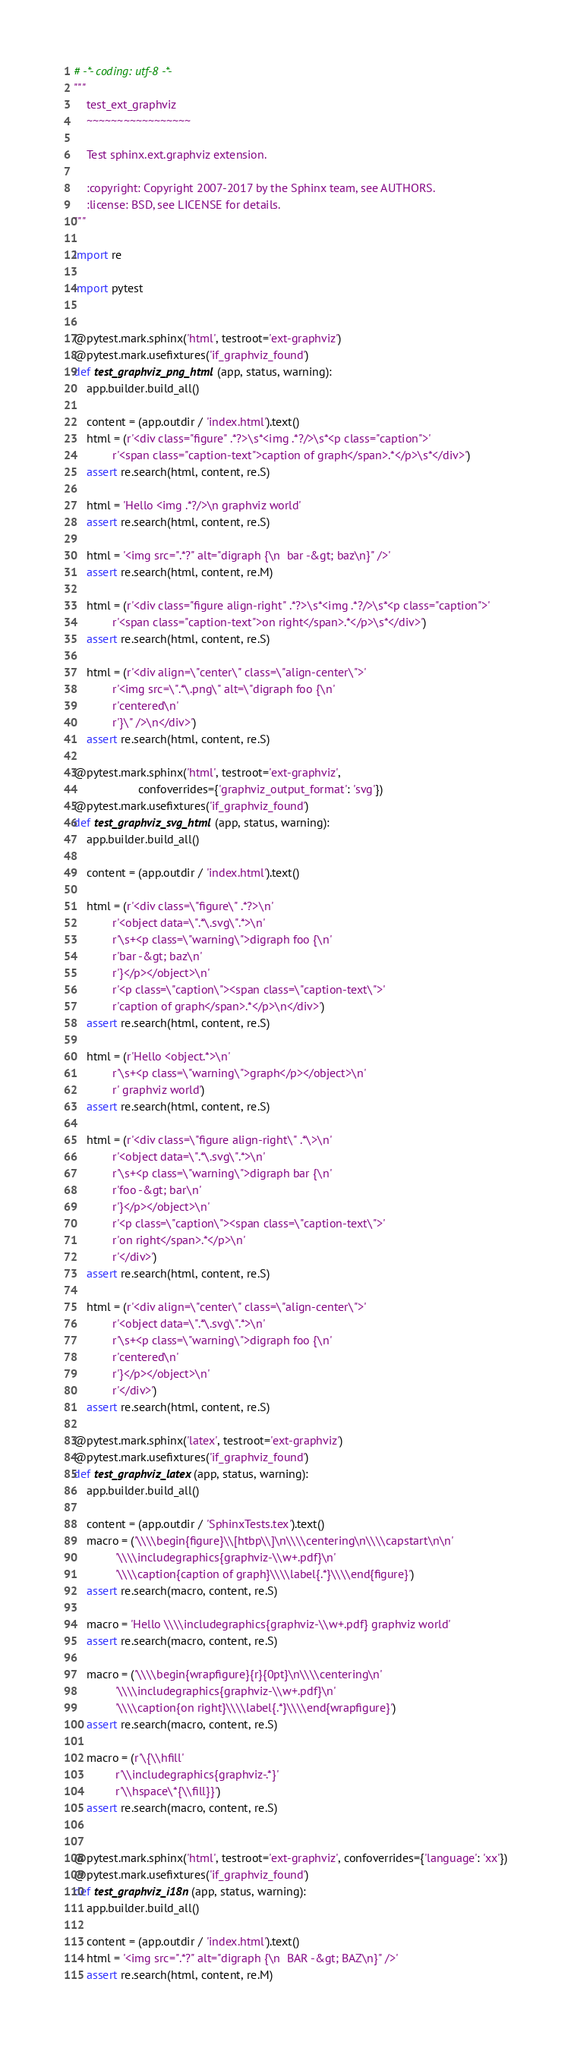Convert code to text. <code><loc_0><loc_0><loc_500><loc_500><_Python_># -*- coding: utf-8 -*-
"""
    test_ext_graphviz
    ~~~~~~~~~~~~~~~~~

    Test sphinx.ext.graphviz extension.

    :copyright: Copyright 2007-2017 by the Sphinx team, see AUTHORS.
    :license: BSD, see LICENSE for details.
"""

import re

import pytest


@pytest.mark.sphinx('html', testroot='ext-graphviz')
@pytest.mark.usefixtures('if_graphviz_found')
def test_graphviz_png_html(app, status, warning):
    app.builder.build_all()

    content = (app.outdir / 'index.html').text()
    html = (r'<div class="figure" .*?>\s*<img .*?/>\s*<p class="caption">'
            r'<span class="caption-text">caption of graph</span>.*</p>\s*</div>')
    assert re.search(html, content, re.S)

    html = 'Hello <img .*?/>\n graphviz world'
    assert re.search(html, content, re.S)

    html = '<img src=".*?" alt="digraph {\n  bar -&gt; baz\n}" />'
    assert re.search(html, content, re.M)

    html = (r'<div class="figure align-right" .*?>\s*<img .*?/>\s*<p class="caption">'
            r'<span class="caption-text">on right</span>.*</p>\s*</div>')
    assert re.search(html, content, re.S)

    html = (r'<div align=\"center\" class=\"align-center\">'
            r'<img src=\".*\.png\" alt=\"digraph foo {\n'
            r'centered\n'
            r'}\" />\n</div>')
    assert re.search(html, content, re.S)

@pytest.mark.sphinx('html', testroot='ext-graphviz',
                    confoverrides={'graphviz_output_format': 'svg'})
@pytest.mark.usefixtures('if_graphviz_found')
def test_graphviz_svg_html(app, status, warning):
    app.builder.build_all()

    content = (app.outdir / 'index.html').text()

    html = (r'<div class=\"figure\" .*?>\n'
            r'<object data=\".*\.svg\".*>\n'
            r'\s+<p class=\"warning\">digraph foo {\n'
            r'bar -&gt; baz\n'
            r'}</p></object>\n'
            r'<p class=\"caption\"><span class=\"caption-text\">'
            r'caption of graph</span>.*</p>\n</div>')
    assert re.search(html, content, re.S)

    html = (r'Hello <object.*>\n'
            r'\s+<p class=\"warning\">graph</p></object>\n'
            r' graphviz world')
    assert re.search(html, content, re.S)

    html = (r'<div class=\"figure align-right\" .*\>\n'
            r'<object data=\".*\.svg\".*>\n'
            r'\s+<p class=\"warning\">digraph bar {\n'
            r'foo -&gt; bar\n'
            r'}</p></object>\n'
            r'<p class=\"caption\"><span class=\"caption-text\">'
            r'on right</span>.*</p>\n'
            r'</div>')
    assert re.search(html, content, re.S)

    html = (r'<div align=\"center\" class=\"align-center\">'
            r'<object data=\".*\.svg\".*>\n'
            r'\s+<p class=\"warning\">digraph foo {\n'
            r'centered\n'
            r'}</p></object>\n'
            r'</div>')
    assert re.search(html, content, re.S)

@pytest.mark.sphinx('latex', testroot='ext-graphviz')
@pytest.mark.usefixtures('if_graphviz_found')
def test_graphviz_latex(app, status, warning):
    app.builder.build_all()

    content = (app.outdir / 'SphinxTests.tex').text()
    macro = ('\\\\begin{figure}\\[htbp\\]\n\\\\centering\n\\\\capstart\n\n'
             '\\\\includegraphics{graphviz-\\w+.pdf}\n'
             '\\\\caption{caption of graph}\\\\label{.*}\\\\end{figure}')
    assert re.search(macro, content, re.S)

    macro = 'Hello \\\\includegraphics{graphviz-\\w+.pdf} graphviz world'
    assert re.search(macro, content, re.S)

    macro = ('\\\\begin{wrapfigure}{r}{0pt}\n\\\\centering\n'
             '\\\\includegraphics{graphviz-\\w+.pdf}\n'
             '\\\\caption{on right}\\\\label{.*}\\\\end{wrapfigure}')
    assert re.search(macro, content, re.S)

    macro = (r'\{\\hfill'
             r'\\includegraphics{graphviz-.*}'
             r'\\hspace\*{\\fill}}')
    assert re.search(macro, content, re.S)


@pytest.mark.sphinx('html', testroot='ext-graphviz', confoverrides={'language': 'xx'})
@pytest.mark.usefixtures('if_graphviz_found')
def test_graphviz_i18n(app, status, warning):
    app.builder.build_all()

    content = (app.outdir / 'index.html').text()
    html = '<img src=".*?" alt="digraph {\n  BAR -&gt; BAZ\n}" />'
    assert re.search(html, content, re.M)
</code> 